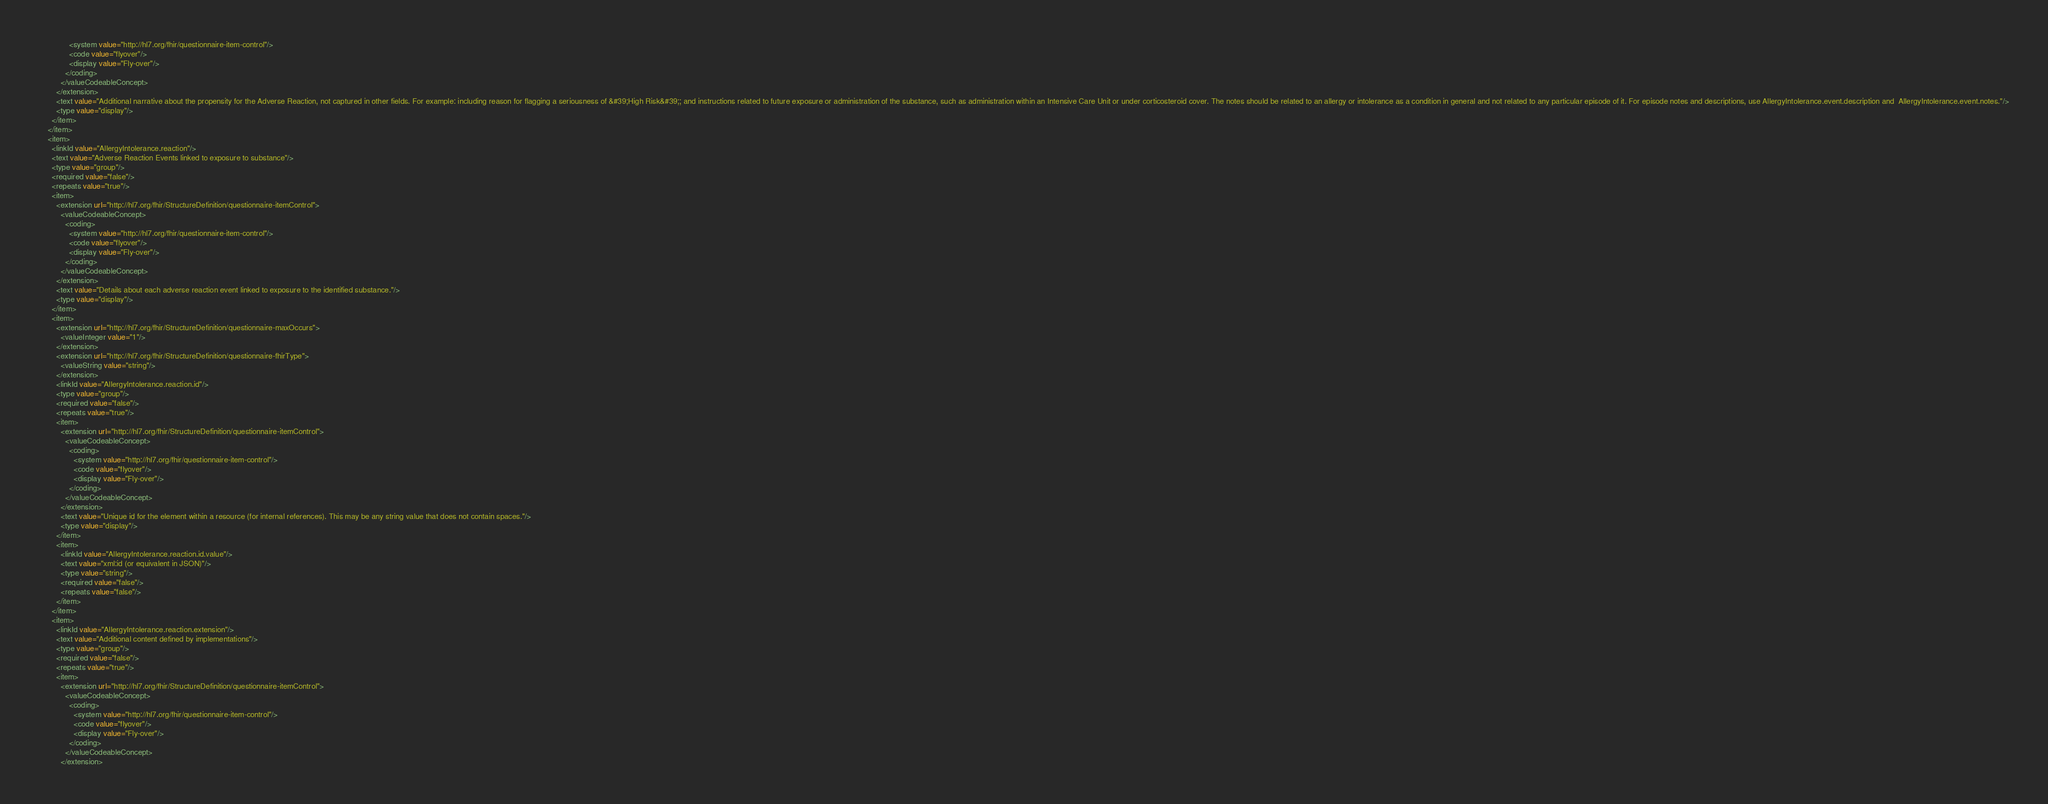<code> <loc_0><loc_0><loc_500><loc_500><_XML_>              <system value="http://hl7.org/fhir/questionnaire-item-control"/>
              <code value="flyover"/>
              <display value="Fly-over"/>
            </coding>
          </valueCodeableConcept>
        </extension>
        <text value="Additional narrative about the propensity for the Adverse Reaction, not captured in other fields. For example: including reason for flagging a seriousness of &#39;High Risk&#39;; and instructions related to future exposure or administration of the substance, such as administration within an Intensive Care Unit or under corticosteroid cover. The notes should be related to an allergy or intolerance as a condition in general and not related to any particular episode of it. For episode notes and descriptions, use AllergyIntolerance.event.description and  AllergyIntolerance.event.notes."/>
        <type value="display"/>
      </item>
    </item>
    <item>
      <linkId value="AllergyIntolerance.reaction"/>
      <text value="Adverse Reaction Events linked to exposure to substance"/>
      <type value="group"/>
      <required value="false"/>
      <repeats value="true"/>
      <item>
        <extension url="http://hl7.org/fhir/StructureDefinition/questionnaire-itemControl">
          <valueCodeableConcept>
            <coding>
              <system value="http://hl7.org/fhir/questionnaire-item-control"/>
              <code value="flyover"/>
              <display value="Fly-over"/>
            </coding>
          </valueCodeableConcept>
        </extension>
        <text value="Details about each adverse reaction event linked to exposure to the identified substance."/>
        <type value="display"/>
      </item>
      <item>
        <extension url="http://hl7.org/fhir/StructureDefinition/questionnaire-maxOccurs">
          <valueInteger value="1"/>
        </extension>
        <extension url="http://hl7.org/fhir/StructureDefinition/questionnaire-fhirType">
          <valueString value="string"/>
        </extension>
        <linkId value="AllergyIntolerance.reaction.id"/>
        <type value="group"/>
        <required value="false"/>
        <repeats value="true"/>
        <item>
          <extension url="http://hl7.org/fhir/StructureDefinition/questionnaire-itemControl">
            <valueCodeableConcept>
              <coding>
                <system value="http://hl7.org/fhir/questionnaire-item-control"/>
                <code value="flyover"/>
                <display value="Fly-over"/>
              </coding>
            </valueCodeableConcept>
          </extension>
          <text value="Unique id for the element within a resource (for internal references). This may be any string value that does not contain spaces."/>
          <type value="display"/>
        </item>
        <item>
          <linkId value="AllergyIntolerance.reaction.id.value"/>
          <text value="xml:id (or equivalent in JSON)"/>
          <type value="string"/>
          <required value="false"/>
          <repeats value="false"/>
        </item>
      </item>
      <item>
        <linkId value="AllergyIntolerance.reaction.extension"/>
        <text value="Additional content defined by implementations"/>
        <type value="group"/>
        <required value="false"/>
        <repeats value="true"/>
        <item>
          <extension url="http://hl7.org/fhir/StructureDefinition/questionnaire-itemControl">
            <valueCodeableConcept>
              <coding>
                <system value="http://hl7.org/fhir/questionnaire-item-control"/>
                <code value="flyover"/>
                <display value="Fly-over"/>
              </coding>
            </valueCodeableConcept>
          </extension></code> 